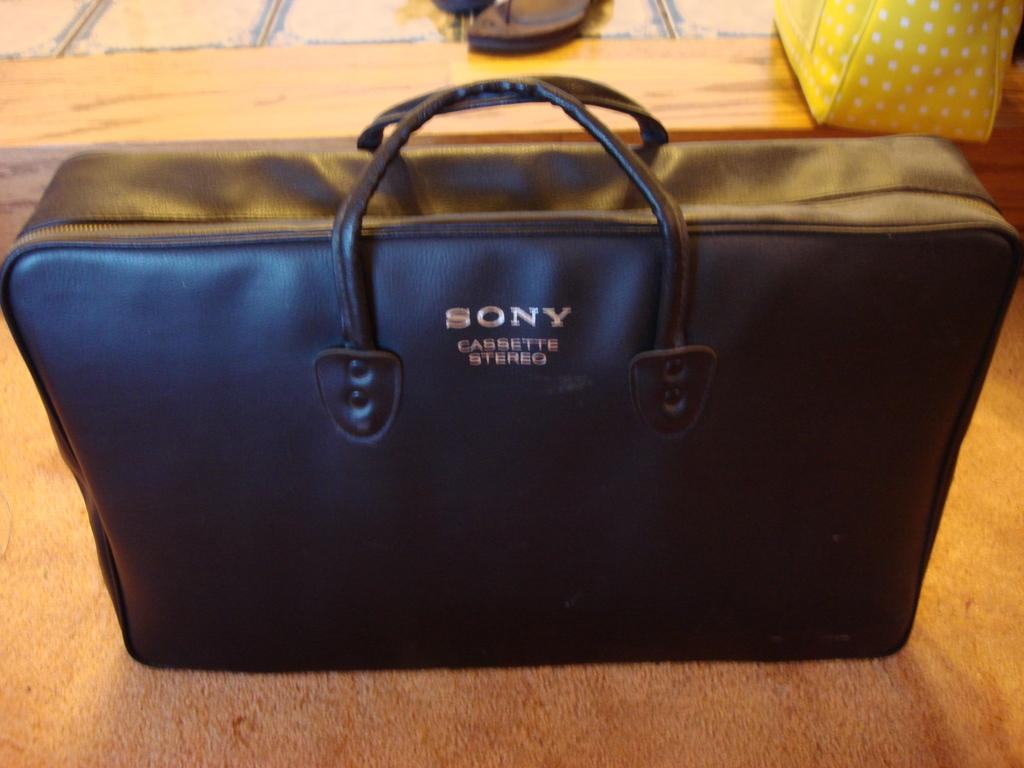What object is present in the image that can be used for carrying items? There is a bag in the image that can be used for carrying items. What is written on the bag? The bag has the words "Sony Cassette Stereo" on it. What type of footwear is on the floor beside the bag? There is a pair of chappals (sandals) on the floor beside the bag. What type of plastic material is used to make the trousers in the image? There are no trousers present in the image, so it is not possible to determine the type of plastic material used. 